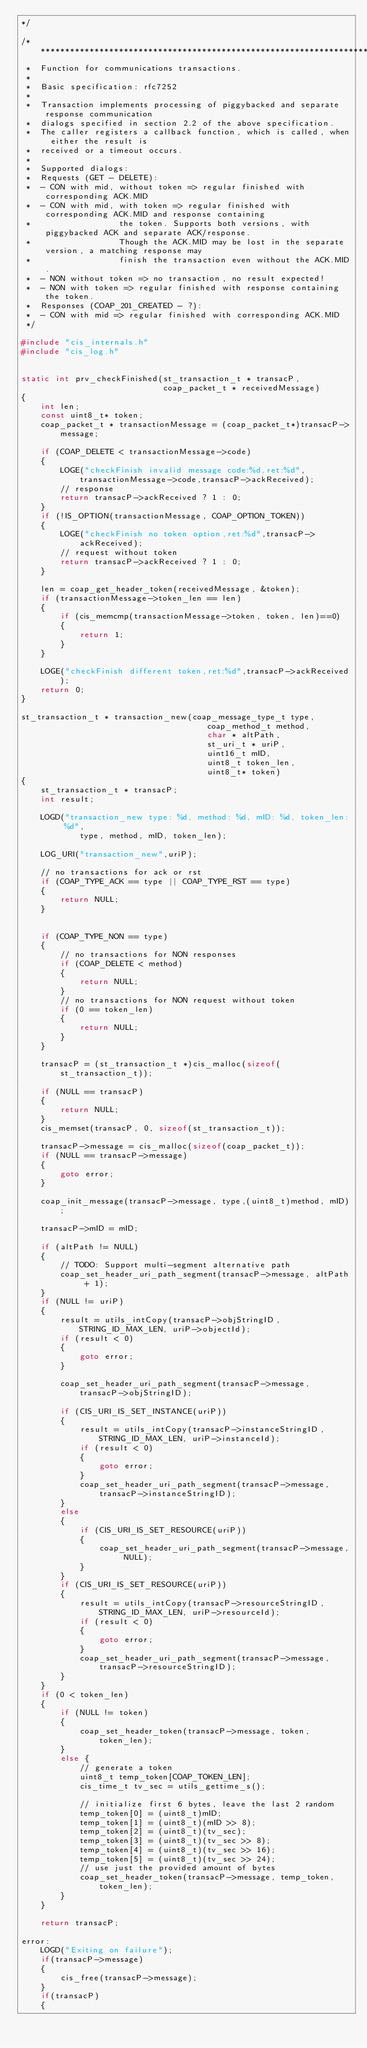Convert code to text. <code><loc_0><loc_0><loc_500><loc_500><_C_>*/

/************************************************************************
 *  Function for communications transactions.
 *
 *  Basic specification: rfc7252
 *
 *  Transaction implements processing of piggybacked and separate response communication
 *  dialogs specified in section 2.2 of the above specification.
 *  The caller registers a callback function, which is called, when either the result is
 *  received or a timeout occurs.
 *
 *  Supported dialogs:
 *  Requests (GET - DELETE):
 *  - CON with mid, without token => regular finished with corresponding ACK.MID
 *  - CON with mid, with token => regular finished with corresponding ACK.MID and response containing
 *                  the token. Supports both versions, with piggybacked ACK and separate ACK/response.
 *                  Though the ACK.MID may be lost in the separate version, a matching response may
 *                  finish the transaction even without the ACK.MID.
 *  - NON without token => no transaction, no result expected!
 *  - NON with token => regular finished with response containing the token.
 *  Responses (COAP_201_CREATED - ?):
 *  - CON with mid => regular finished with corresponding ACK.MID
 */

#include "cis_internals.h"
#include "cis_log.h"


static int prv_checkFinished(st_transaction_t * transacP,
                             coap_packet_t * receivedMessage)
{
    int len;
    const uint8_t* token;
    coap_packet_t * transactionMessage = (coap_packet_t*)transacP->message;

    if (COAP_DELETE < transactionMessage->code)
    {
        LOGE("checkFinish invalid message code:%d,ret:%d",transactionMessage->code,transacP->ackReceived);
        // response
        return transacP->ackReceived ? 1 : 0;
    }
    if (!IS_OPTION(transactionMessage, COAP_OPTION_TOKEN))
    {
        LOGE("checkFinish no token option,ret:%d",transacP->ackReceived);
        // request without token
        return transacP->ackReceived ? 1 : 0;
    }

    len = coap_get_header_token(receivedMessage, &token);
    if (transactionMessage->token_len == len)
    {
        if (cis_memcmp(transactionMessage->token, token, len)==0) 
        {
            return 1;
        }
    }

    LOGE("checkFinish different token,ret:%d",transacP->ackReceived);
    return 0;
}

st_transaction_t * transaction_new(coap_message_type_t type,
                                      coap_method_t method,
                                      char * altPath,
                                      st_uri_t * uriP,
                                      uint16_t mID,
                                      uint8_t token_len,
                                      uint8_t* token)
{
    st_transaction_t * transacP;
    int result;

    LOGD("transaction_new type: %d, method: %d, mID: %d, token_len: %d",
            type, method, mID, token_len);
    
    LOG_URI("transaction_new",uriP);

    // no transactions for ack or rst
    if (COAP_TYPE_ACK == type || COAP_TYPE_RST == type) 
    {
        return NULL;
    }


    if (COAP_TYPE_NON == type)
    {
        // no transactions for NON responses
        if (COAP_DELETE < method) 
        {
            return NULL;
        }
        // no transactions for NON request without token
        if (0 == token_len) 
        {
            return NULL;
        }
    }

    transacP = (st_transaction_t *)cis_malloc(sizeof(st_transaction_t));

    if (NULL == transacP) 
    {
        return NULL;
    }
    cis_memset(transacP, 0, sizeof(st_transaction_t));

    transacP->message = cis_malloc(sizeof(coap_packet_t));
    if (NULL == transacP->message) 
    {
        goto error;
    }

    coap_init_message(transacP->message, type,(uint8_t)method, mID);

    transacP->mID = mID;

    if (altPath != NULL)
    {
        // TODO: Support multi-segment alternative path
        coap_set_header_uri_path_segment(transacP->message, altPath + 1);
    }
    if (NULL != uriP)
    {
        result = utils_intCopy(transacP->objStringID, STRING_ID_MAX_LEN, uriP->objectId);
        if (result < 0) 
        {
            goto error;
        }

        coap_set_header_uri_path_segment(transacP->message, transacP->objStringID);

        if (CIS_URI_IS_SET_INSTANCE(uriP))
        {
            result = utils_intCopy(transacP->instanceStringID, STRING_ID_MAX_LEN, uriP->instanceId);
            if (result < 0) 
            {
                goto error;
            }
            coap_set_header_uri_path_segment(transacP->message, transacP->instanceStringID);
        }
        else
        {
            if (CIS_URI_IS_SET_RESOURCE(uriP))
            {
                coap_set_header_uri_path_segment(transacP->message, NULL);
            }
        }
        if (CIS_URI_IS_SET_RESOURCE(uriP))
        {
            result = utils_intCopy(transacP->resourceStringID, STRING_ID_MAX_LEN, uriP->resourceId);
            if (result < 0) 
            {
                goto error;
            }
            coap_set_header_uri_path_segment(transacP->message, transacP->resourceStringID);
        }
    }
    if (0 < token_len)
    {
        if (NULL != token)
        {
            coap_set_header_token(transacP->message, token, token_len);
        }
        else {
            // generate a token
            uint8_t temp_token[COAP_TOKEN_LEN];
            cis_time_t tv_sec = utils_gettime_s();

            // initialize first 6 bytes, leave the last 2 random
            temp_token[0] = (uint8_t)mID;
            temp_token[1] = (uint8_t)(mID >> 8);
            temp_token[2] = (uint8_t)(tv_sec);
            temp_token[3] = (uint8_t)(tv_sec >> 8);
            temp_token[4] = (uint8_t)(tv_sec >> 16);
            temp_token[5] = (uint8_t)(tv_sec >> 24);
            // use just the provided amount of bytes
            coap_set_header_token(transacP->message, temp_token, token_len);
        }
    }

    return transacP;

error:
    LOGD("Exiting on failure");
    if(transacP->message)
    {
        cis_free(transacP->message);
    }
    if(transacP)
    {</code> 